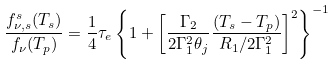<formula> <loc_0><loc_0><loc_500><loc_500>\frac { f ^ { s } _ { \nu , s } ( T _ { s } ) } { f _ { \nu } ( T _ { p } ) } = \frac { 1 } { 4 } \tau _ { e } \left \{ 1 + \left [ \frac { \Gamma _ { 2 } } { 2 \Gamma _ { 1 } ^ { 2 } \theta _ { j } } \frac { ( T _ { s } - T _ { p } ) } { R _ { 1 } / 2 \Gamma _ { 1 } ^ { 2 } } \right ] ^ { 2 } \right \} ^ { - 1 }</formula> 